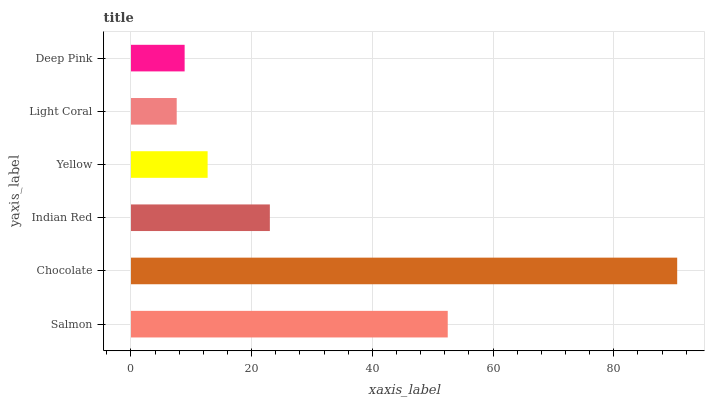Is Light Coral the minimum?
Answer yes or no. Yes. Is Chocolate the maximum?
Answer yes or no. Yes. Is Indian Red the minimum?
Answer yes or no. No. Is Indian Red the maximum?
Answer yes or no. No. Is Chocolate greater than Indian Red?
Answer yes or no. Yes. Is Indian Red less than Chocolate?
Answer yes or no. Yes. Is Indian Red greater than Chocolate?
Answer yes or no. No. Is Chocolate less than Indian Red?
Answer yes or no. No. Is Indian Red the high median?
Answer yes or no. Yes. Is Yellow the low median?
Answer yes or no. Yes. Is Deep Pink the high median?
Answer yes or no. No. Is Chocolate the low median?
Answer yes or no. No. 